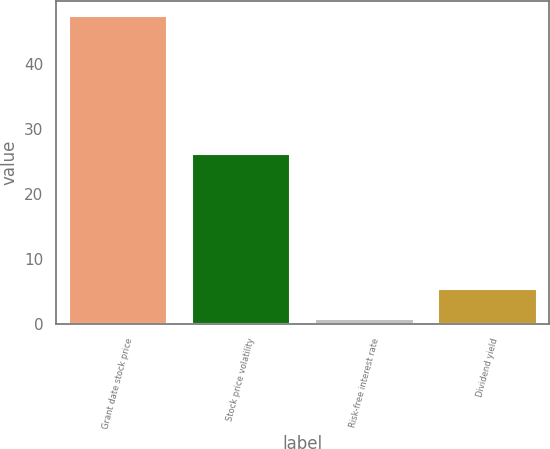Convert chart to OTSL. <chart><loc_0><loc_0><loc_500><loc_500><bar_chart><fcel>Grant date stock price<fcel>Stock price volatility<fcel>Risk-free interest rate<fcel>Dividend yield<nl><fcel>47.28<fcel>26.12<fcel>0.65<fcel>5.31<nl></chart> 